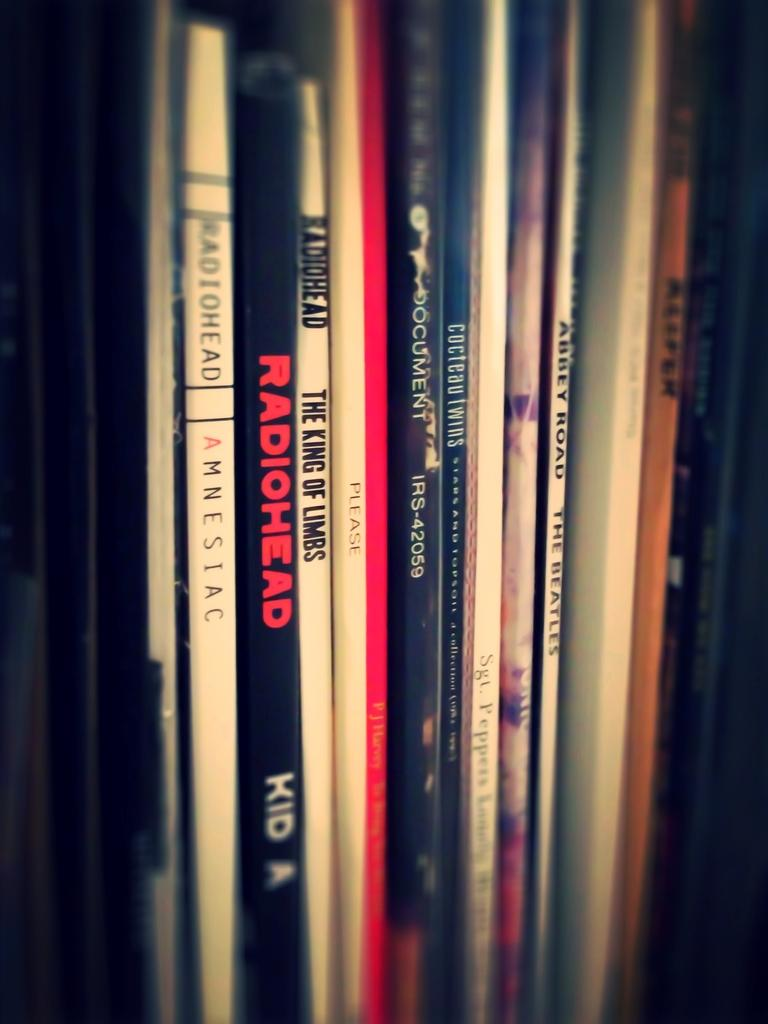Provide a one-sentence caption for the provided image. A row of music CDs include titles by Radiohead and the Beatles. 